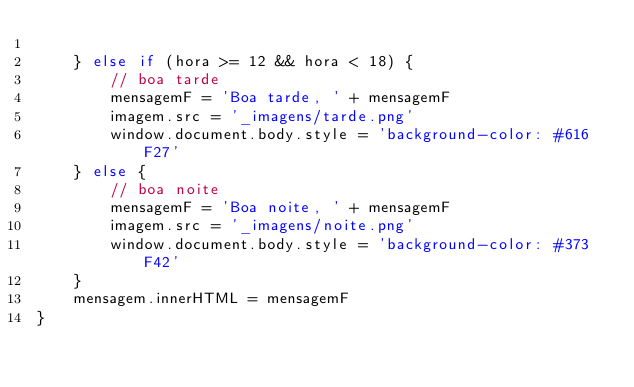<code> <loc_0><loc_0><loc_500><loc_500><_JavaScript_>
    } else if (hora >= 12 && hora < 18) {
        // boa tarde
        mensagemF = 'Boa tarde, ' + mensagemF
        imagem.src = '_imagens/tarde.png'
        window.document.body.style = 'background-color: #616F27'
    } else {
        // boa noite
        mensagemF = 'Boa noite, ' + mensagemF
        imagem.src = '_imagens/noite.png'
        window.document.body.style = 'background-color: #373F42'
    }
    mensagem.innerHTML = mensagemF
}</code> 